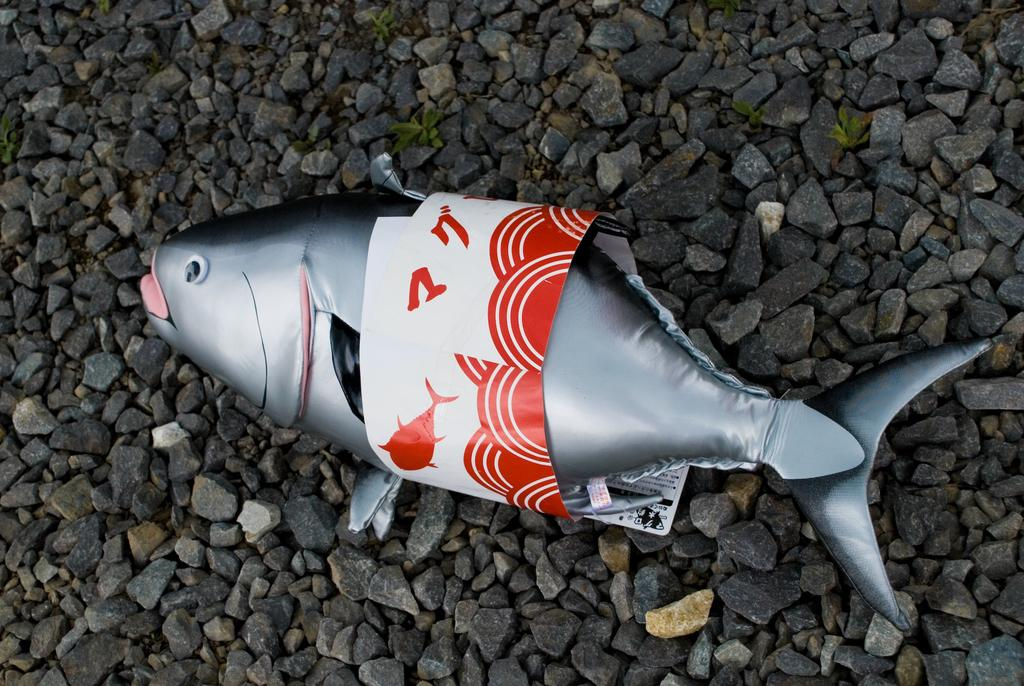What shape is the balloon in the image? The balloon in the image is fish-shaped. Where is the balloon located? The balloon is on rocks. What else can be seen on the rocks? There are plants on the rocks. What type of wood is used to make the tray in the image? There is no tray present in the image. What design is featured on the balloon in the image? The provided facts do not mention any specific design on the balloon; it is simply described as fish-shaped. 